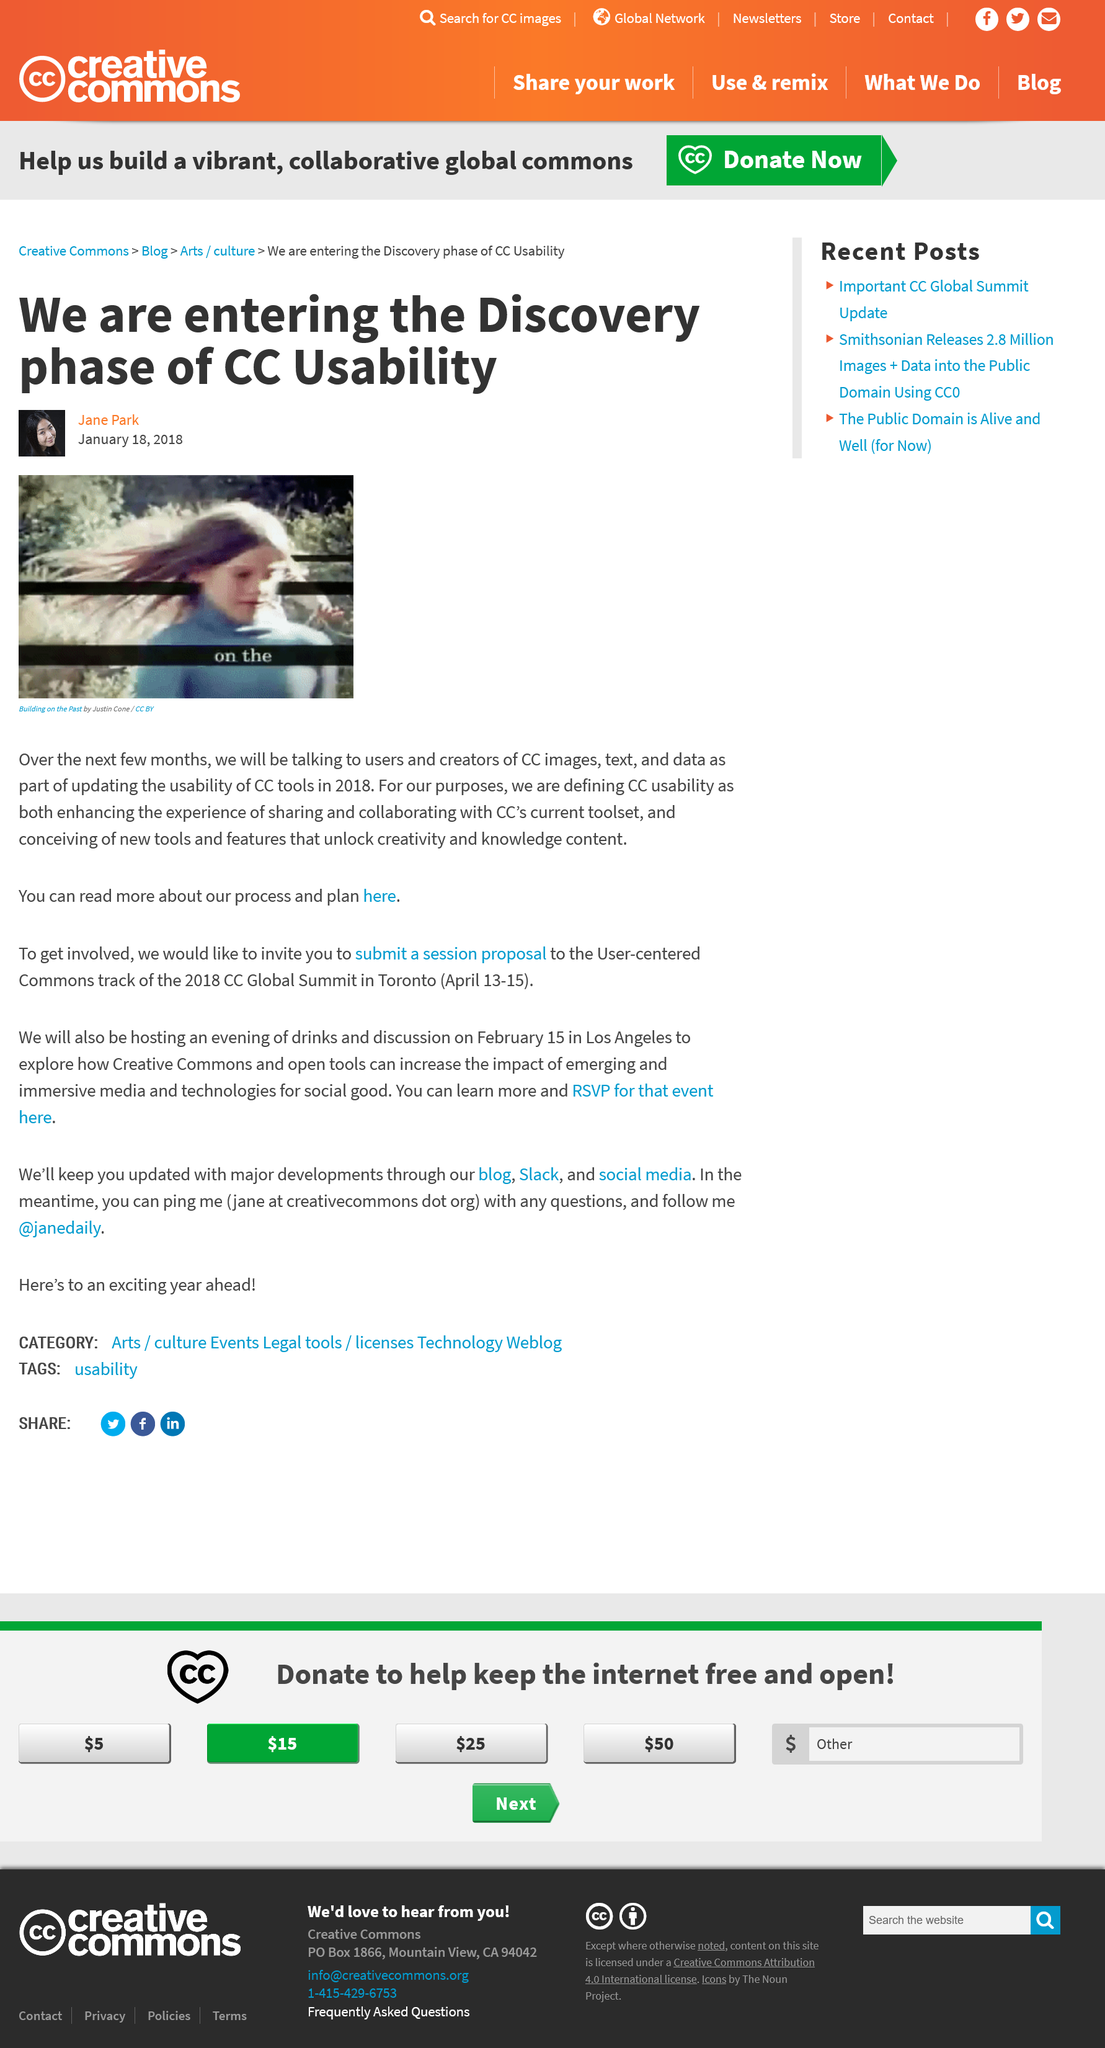Give some essential details in this illustration. The main image displayed is "Building on the Past" by Justin Cone. CC usability enhances the experience of sharing and collaborating with CC's current toolset, as well as the development of new tools to unlock content, to provide an optimal user experience. We are currently in the discovery phase of CC usability. 